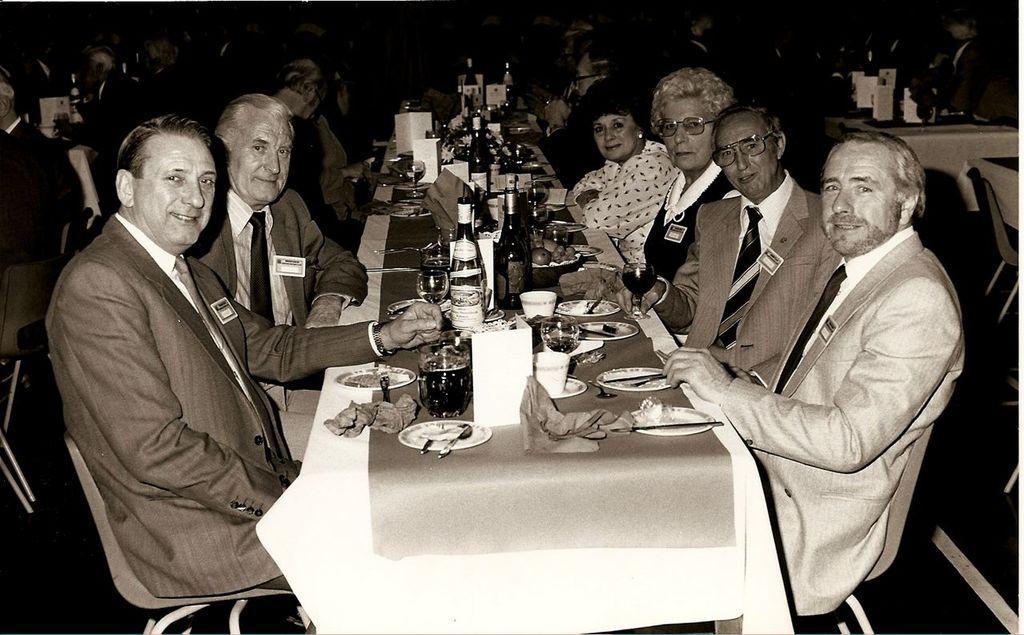Please provide a concise description of this image. In this image there are group of people sitting on the chair. On the table there is a plate,spoon. tissue,glass,bottle,fruits and some food material. 